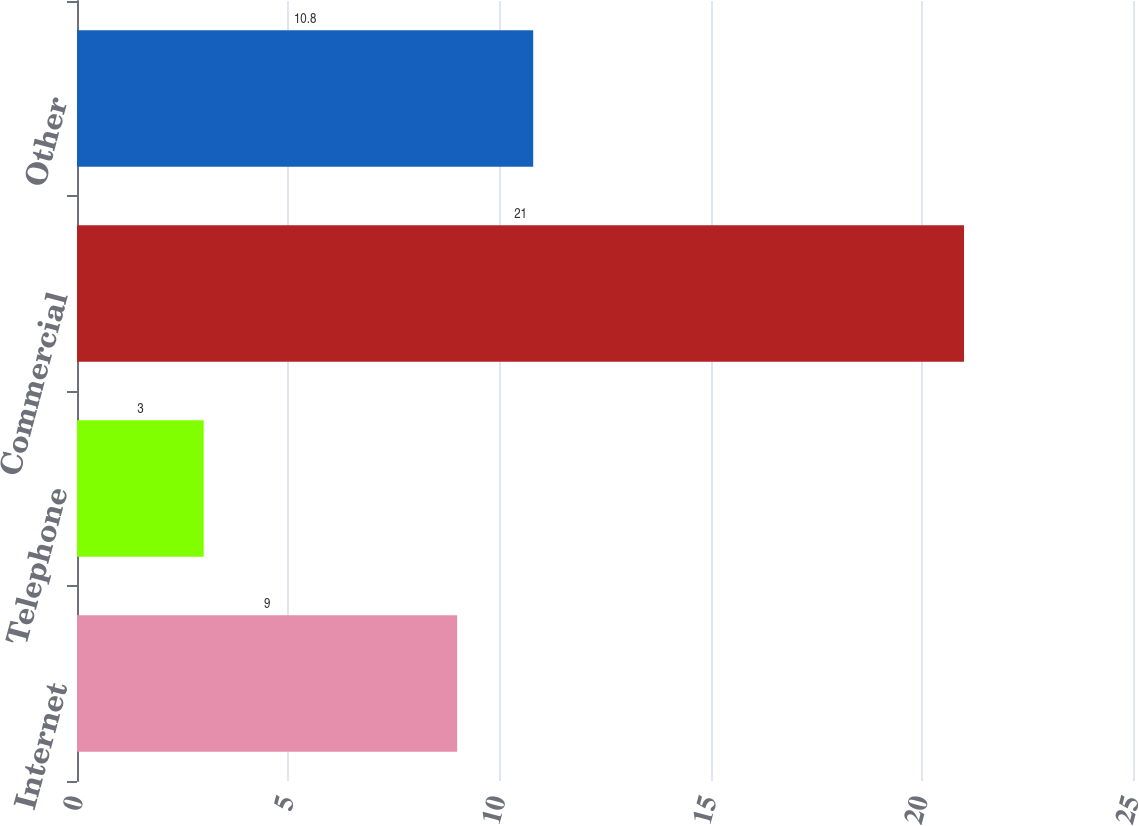Convert chart to OTSL. <chart><loc_0><loc_0><loc_500><loc_500><bar_chart><fcel>Internet<fcel>Telephone<fcel>Commercial<fcel>Other<nl><fcel>9<fcel>3<fcel>21<fcel>10.8<nl></chart> 